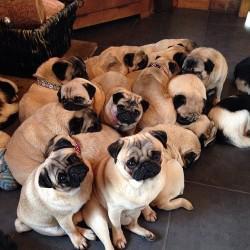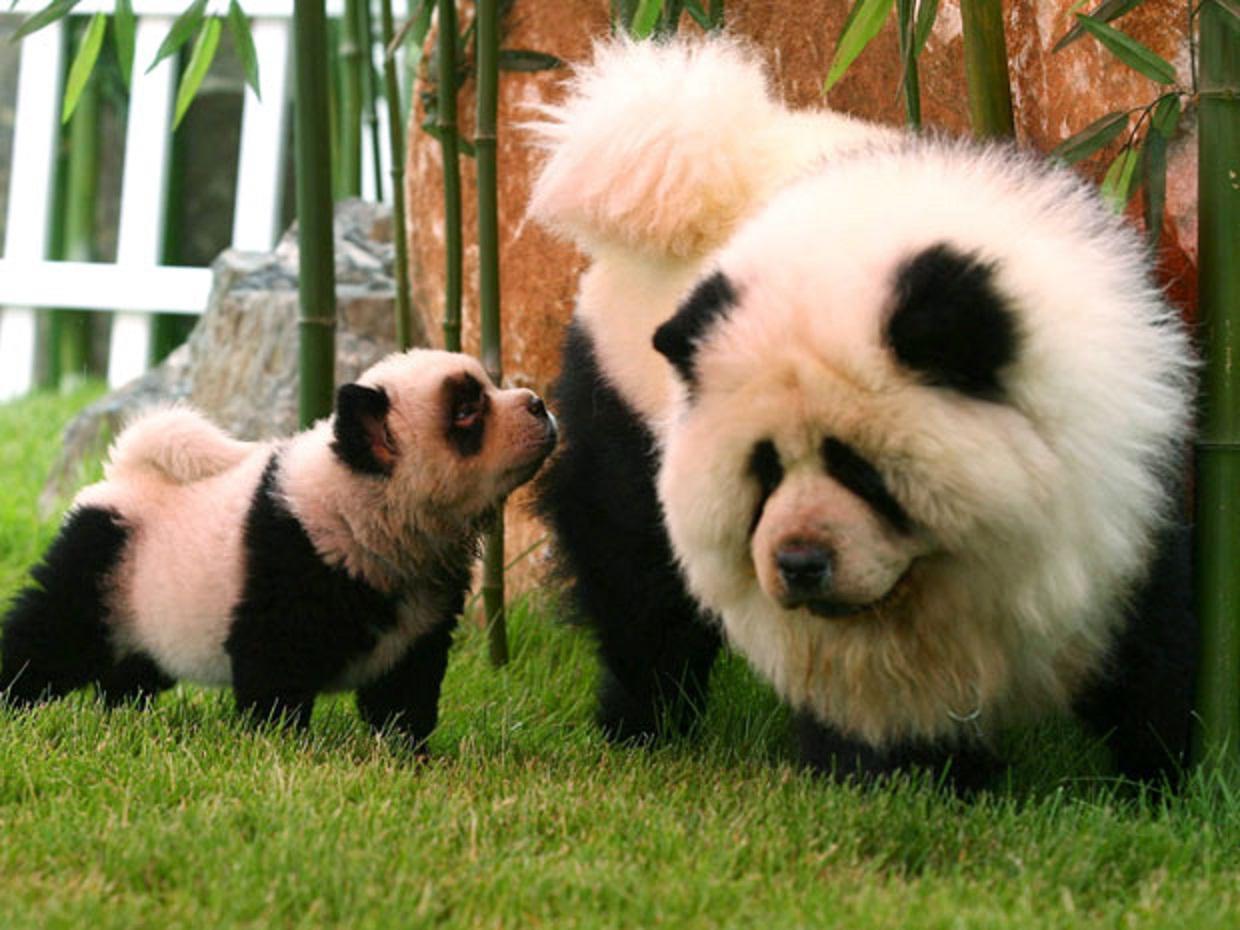The first image is the image on the left, the second image is the image on the right. Analyze the images presented: Is the assertion "One of the images contains at least four dogs." valid? Answer yes or no. Yes. 